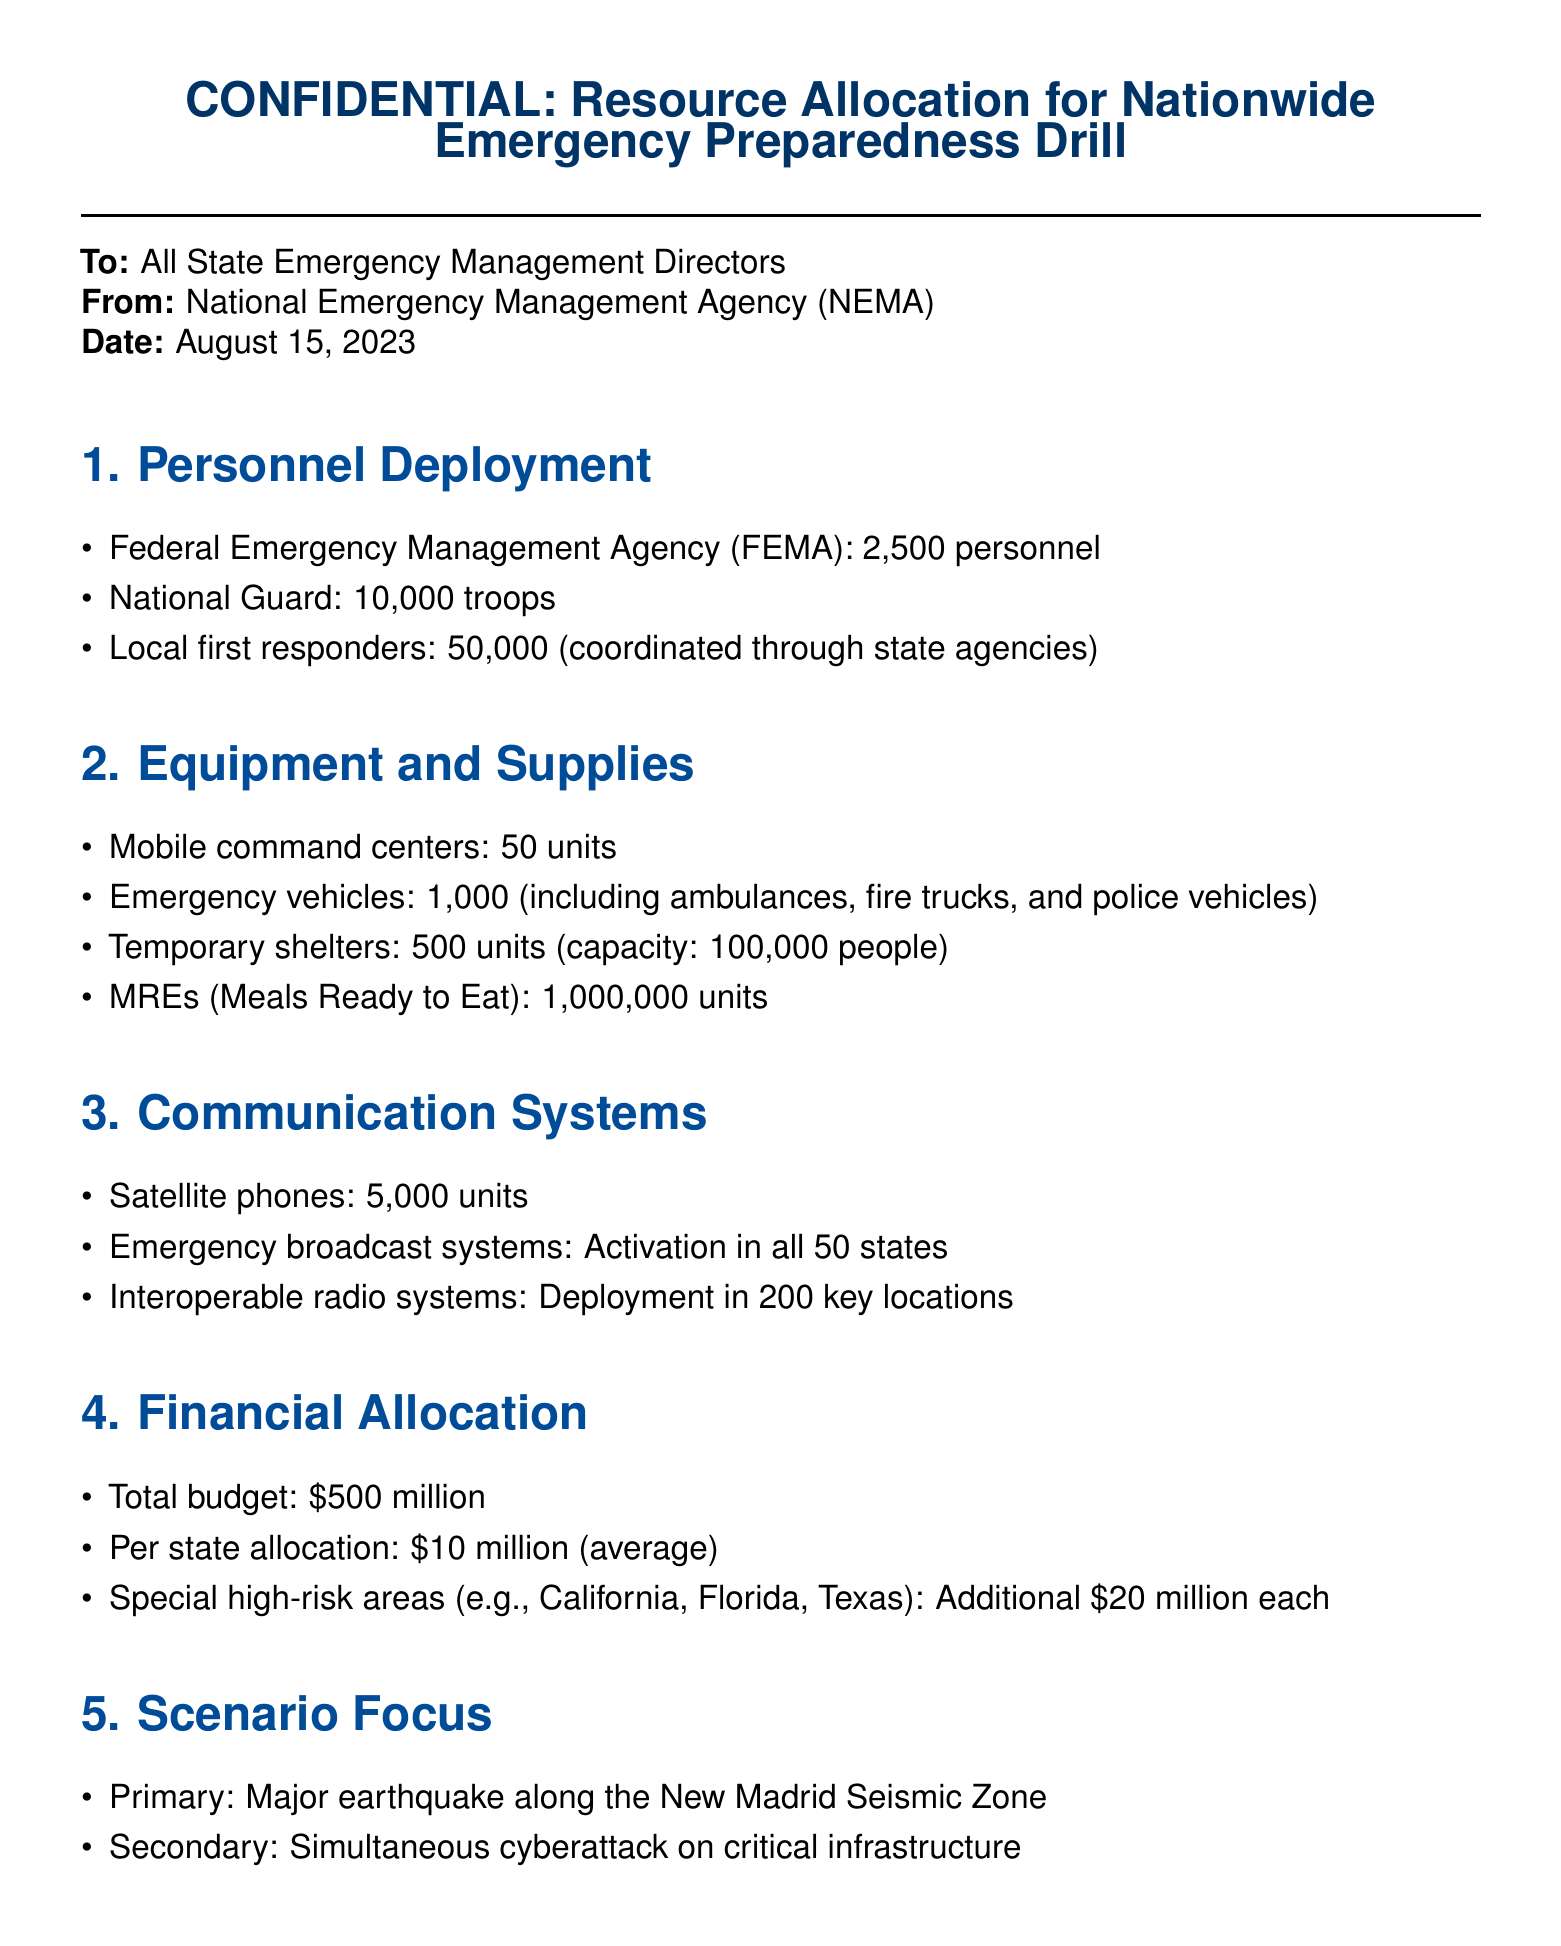What is the total number of FEMA personnel deployed? The number of FEMA personnel deployed is explicitly stated in the document under Personnel Deployment.
Answer: 2,500 personnel How many troops from the National Guard will be participating? The document provides the exact number of troops from the National Guard under Personnel Deployment.
Answer: 10,000 troops What is the capacity of the temporary shelters? The capacity of temporary shelters is described in the Equipment and Supplies section.
Answer: 100,000 people What is the total budget allocated for the drill? The total budget is outlined in the Financial Allocation section of the document.
Answer: $500 million Which states receive additional high-risk area funding? The document specifies the states recognized as high-risk areas, which receive extra funding.
Answer: California, Florida, Texas What type of disaster scenario is the primary focus? The primary focus disaster scenario is mentioned in the Scenario Focus section.
Answer: Major earthquake How long is the preparation phase before the drill execution? The duration of the preparation phase is detailed in the Timeline section.
Answer: 3 months How many mobile command centers are allocated for the drill? The number of mobile command centers is listed under Equipment and Supplies in the document.
Answer: 50 units How many units of MREs are allocated? The document states the number of MREs available under Equipment and Supplies.
Answer: 1,000,000 units 